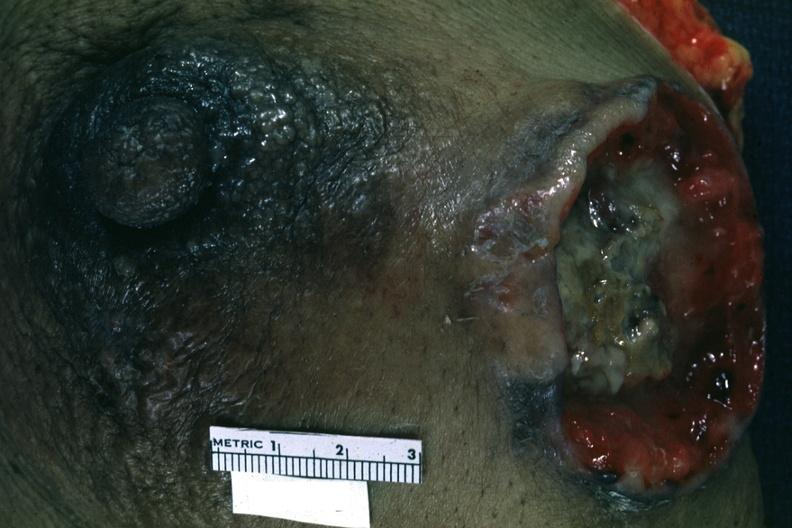does this image show close-up excised breast with large ulcerating carcinoma?
Answer the question using a single word or phrase. Yes 